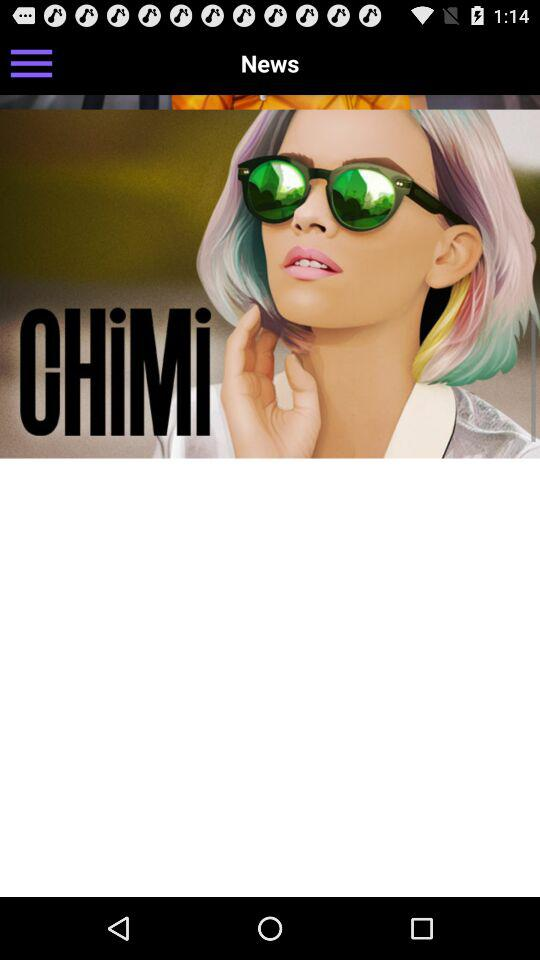What is the name of the application? The name of the application is "CHiMi". 